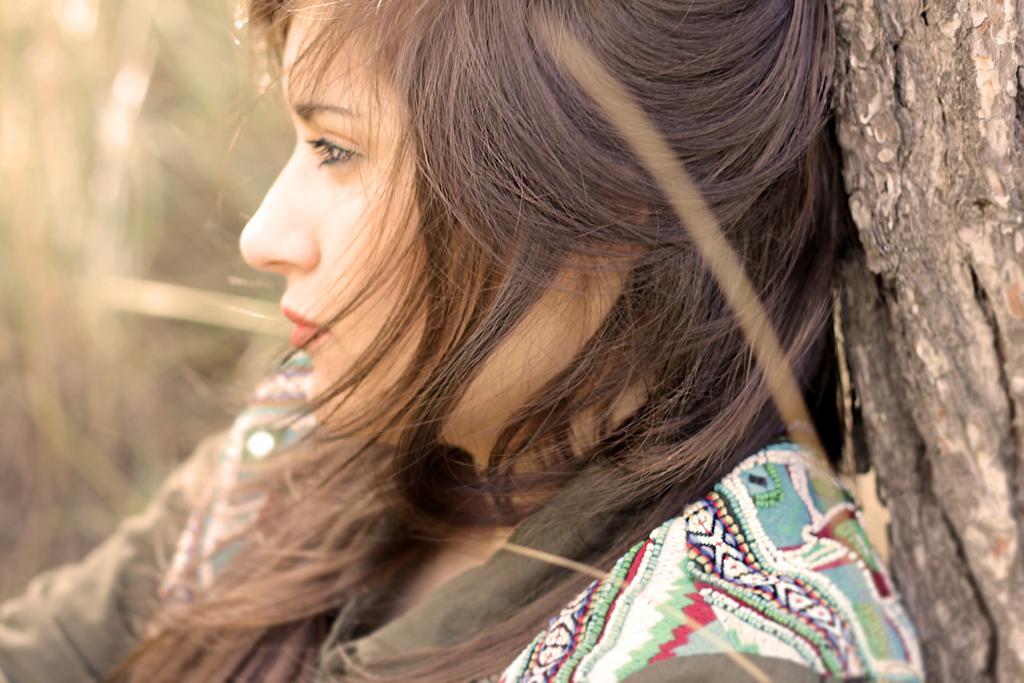Please provide a concise description of this image. In this image I can see there is an image of a woman sitting in the tree and the background of the image is blurred. 